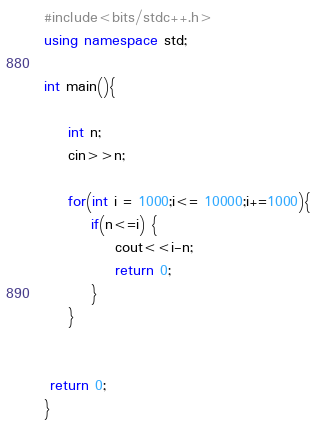Convert code to text. <code><loc_0><loc_0><loc_500><loc_500><_C++_>#include<bits/stdc++.h>
using namespace std;
 
int main(){
 
    int n;
    cin>>n;
    
    for(int i = 1000;i<= 10000;i+=1000){
        if(n<=i) {
            cout<<i-n;
            return 0;
        }
    }
    
    
 return 0;
}</code> 